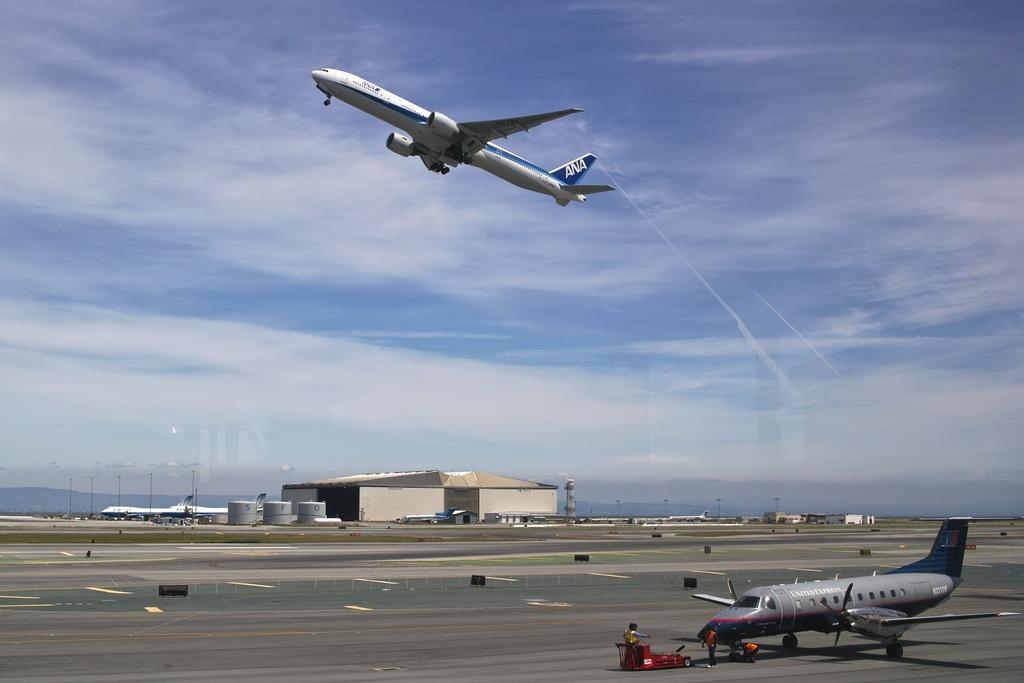Could you give a brief overview of what you see in this image? In this image I can see a aircraft which is white and blue in color is flying in the air. I can see another aircraft which is grey in color on the runway and few persons standing in front of it. In the background I can see few other aircraft is, a building, few runways and the sky. 